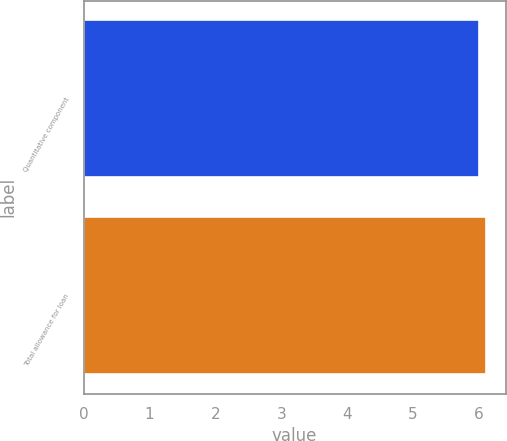<chart> <loc_0><loc_0><loc_500><loc_500><bar_chart><fcel>Quantitative component<fcel>Total allowance for loan<nl><fcel>6<fcel>6.1<nl></chart> 